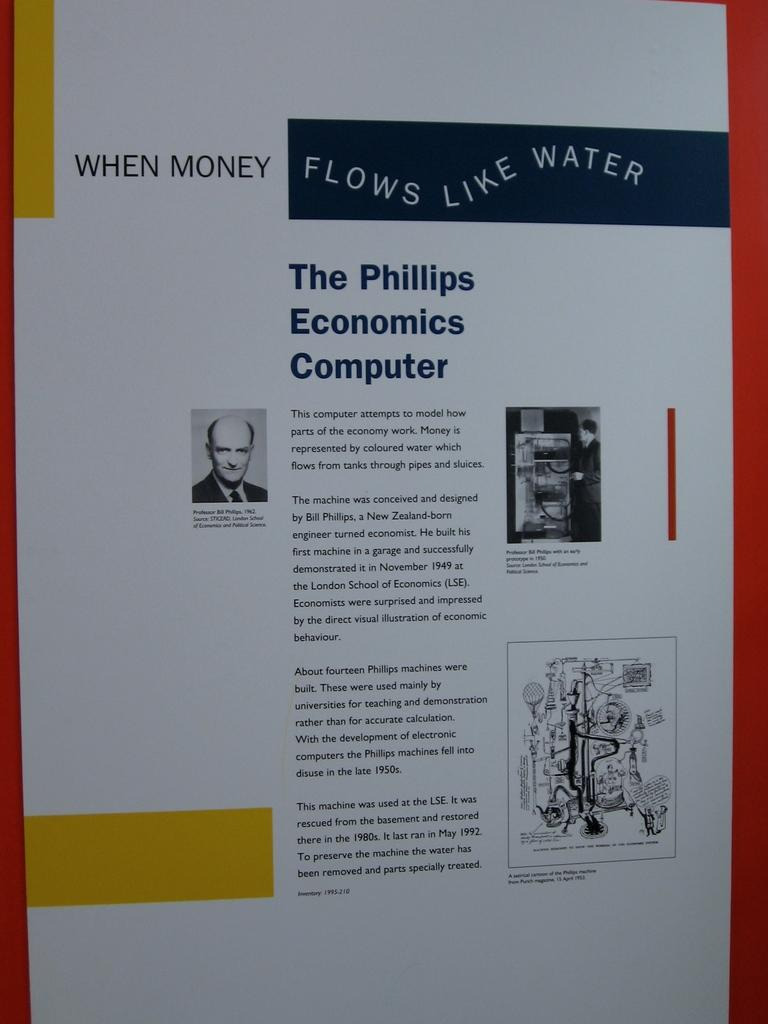<image>
Summarize the visual content of the image. The paper shown suggests that money can flow like water. 